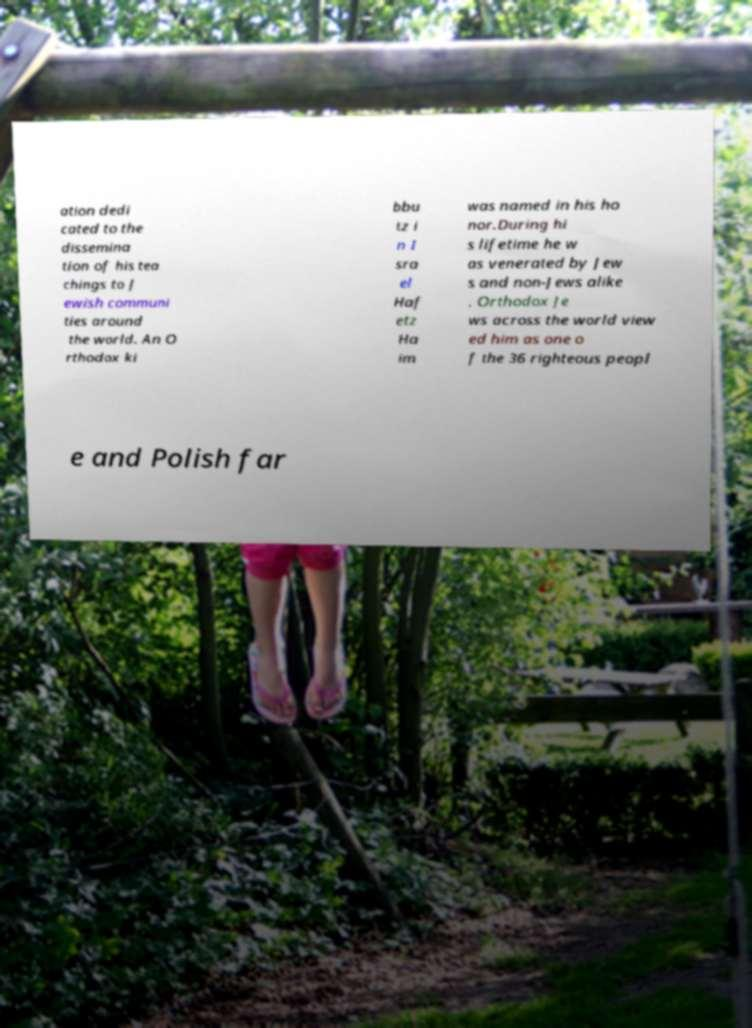For documentation purposes, I need the text within this image transcribed. Could you provide that? ation dedi cated to the dissemina tion of his tea chings to J ewish communi ties around the world. An O rthodox ki bbu tz i n I sra el Haf etz Ha im was named in his ho nor.During hi s lifetime he w as venerated by Jew s and non-Jews alike . Orthodox Je ws across the world view ed him as one o f the 36 righteous peopl e and Polish far 